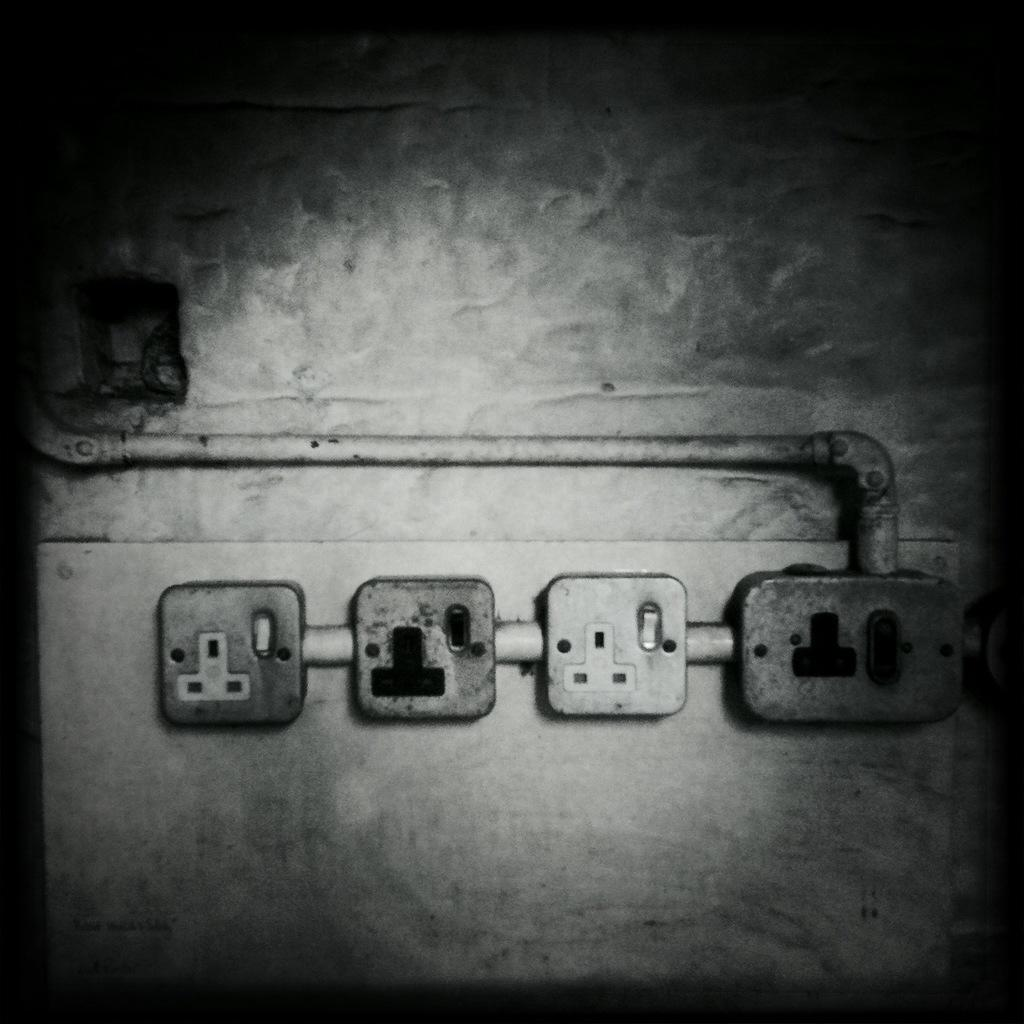What type of objects can be seen on the wall in the image? There are sockets and a pipe on the wall in the image. What is the color scheme of the image? The image is black and white. What type of net is visible in the image? There is no net present in the image. What kind of drug can be seen in the image? There is no drug present in the image. 